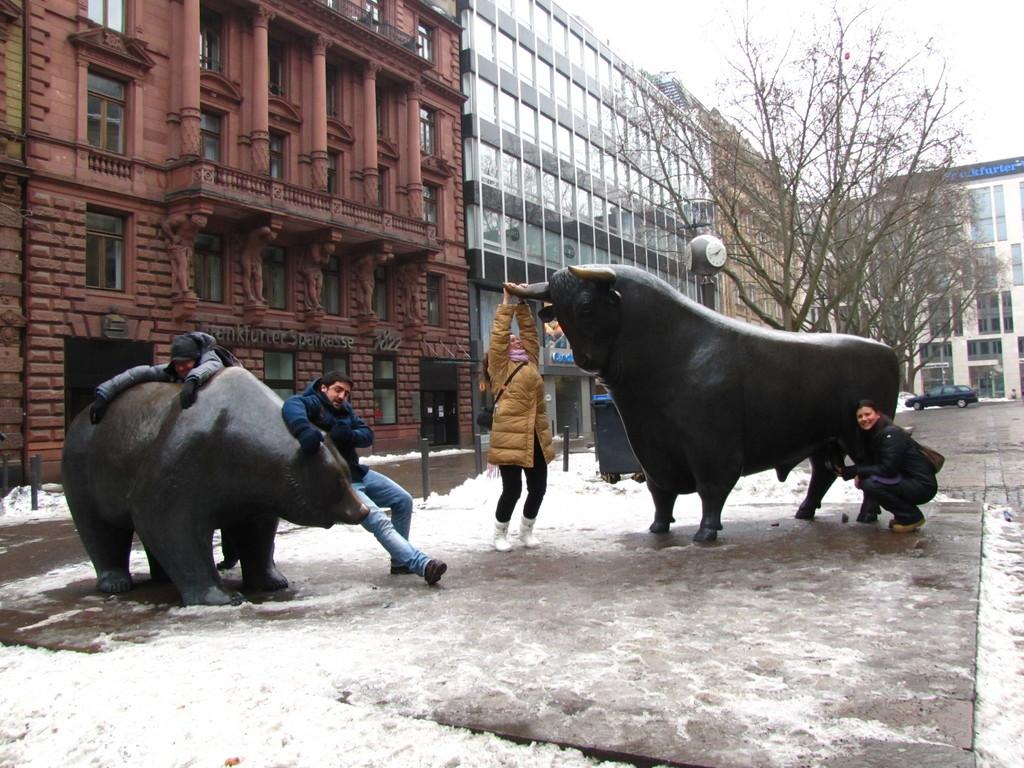How many people are in the image? There are people in the image, but the exact number is not specified. What position is one of the people in? One person is sitting in a squat position. What animals are present in the image? There are bulls in the image. What is the weather like in the image? There is snow visible in the image, indicating a cold and snowy environment. What structures can be seen in the background of the image? There are buildings, windows, and trees visible in the background of the image. What part of the natural environment is visible in the image? The sky is visible in the background of the image. What type of lace is being used to decorate the bulls in the image? There is no lace present in the image, nor is there any indication that the bulls are being decorated. 